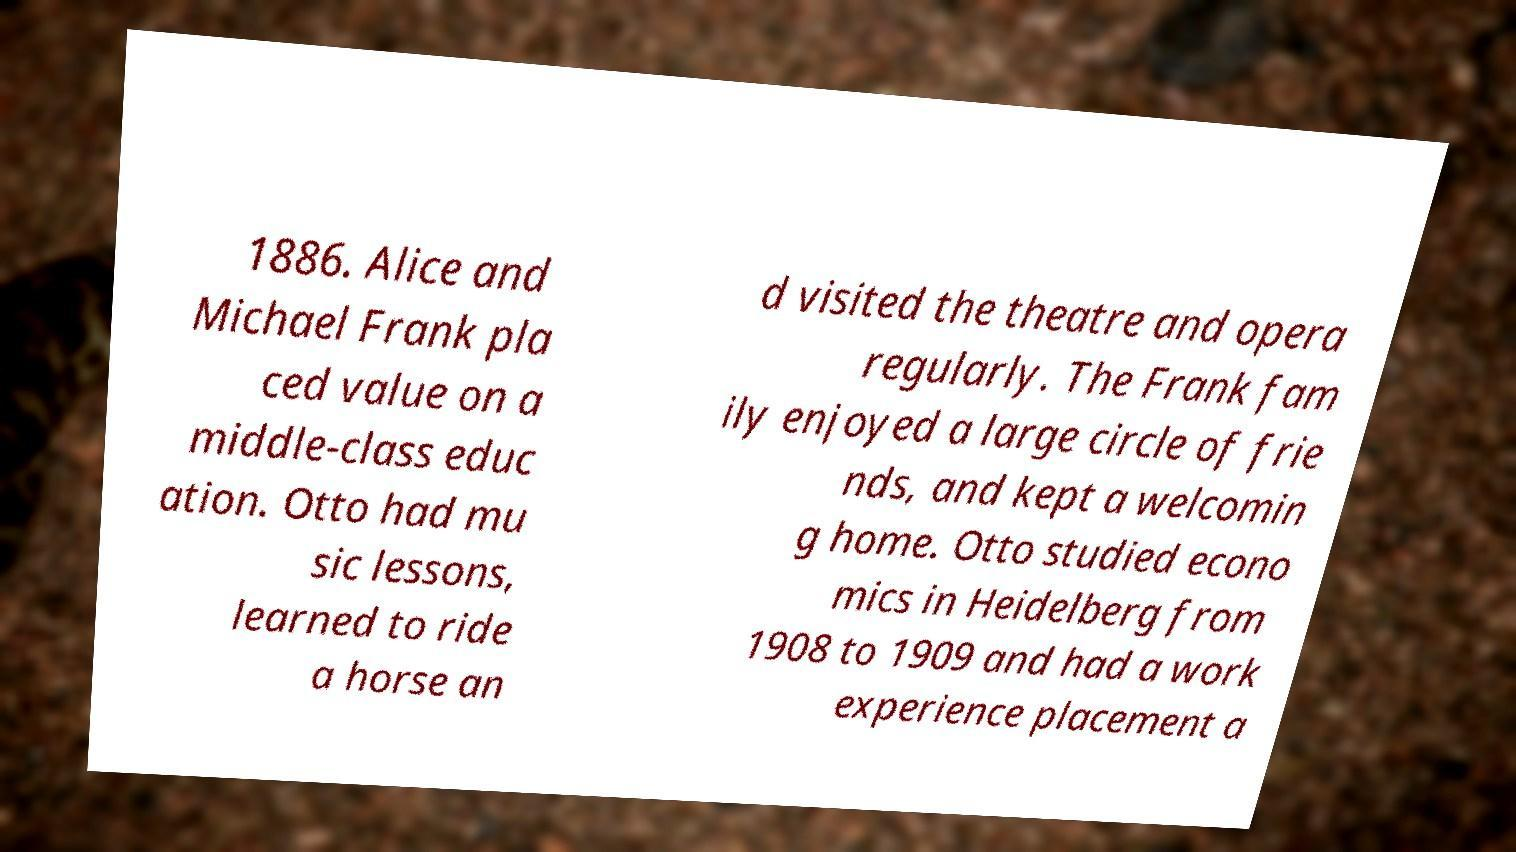For documentation purposes, I need the text within this image transcribed. Could you provide that? 1886. Alice and Michael Frank pla ced value on a middle-class educ ation. Otto had mu sic lessons, learned to ride a horse an d visited the theatre and opera regularly. The Frank fam ily enjoyed a large circle of frie nds, and kept a welcomin g home. Otto studied econo mics in Heidelberg from 1908 to 1909 and had a work experience placement a 